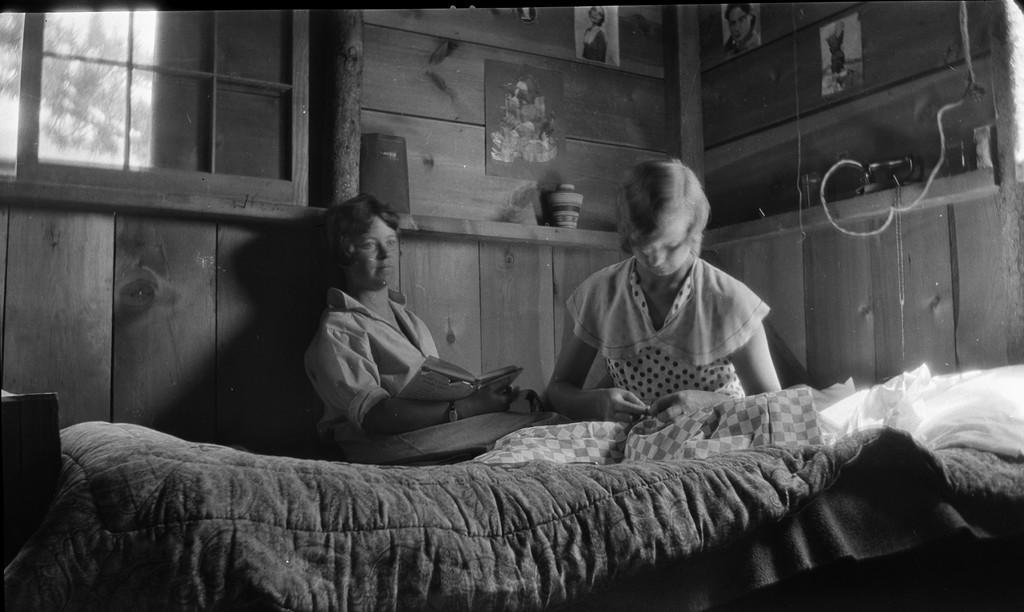Could you give a brief overview of what you see in this image? In this image I see 2 girls who are on the bed and this girl is holding a book. In the background I see the wall, few photos on it and the window. 